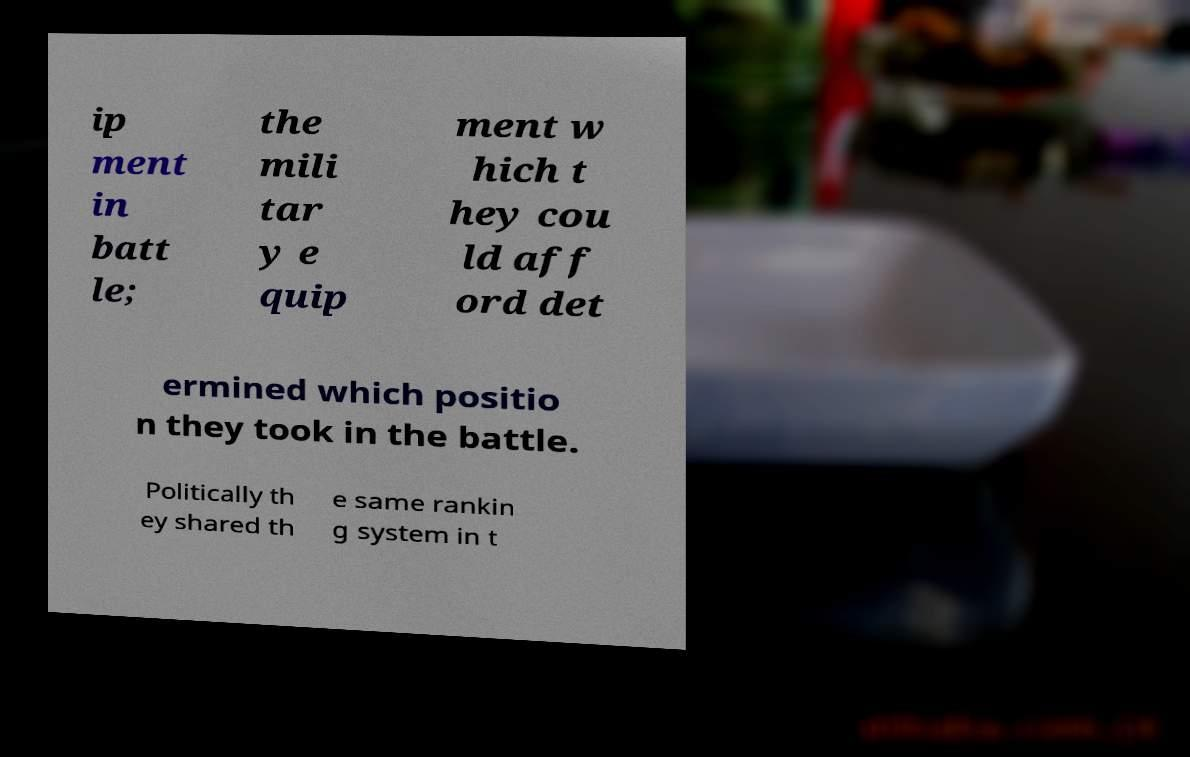Can you read and provide the text displayed in the image?This photo seems to have some interesting text. Can you extract and type it out for me? ip ment in batt le; the mili tar y e quip ment w hich t hey cou ld aff ord det ermined which positio n they took in the battle. Politically th ey shared th e same rankin g system in t 